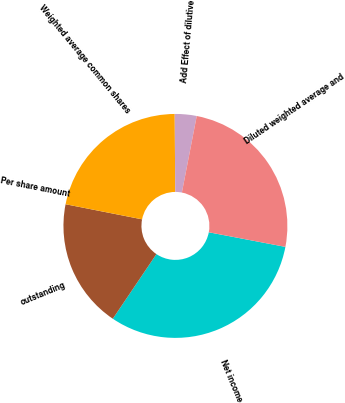<chart> <loc_0><loc_0><loc_500><loc_500><pie_chart><fcel>Net income<fcel>outstanding<fcel>Per share amount<fcel>Weighted average common shares<fcel>Add Effect of dilutive<fcel>Diluted weighted average and<nl><fcel>31.45%<fcel>18.66%<fcel>0.0%<fcel>21.8%<fcel>3.15%<fcel>24.95%<nl></chart> 